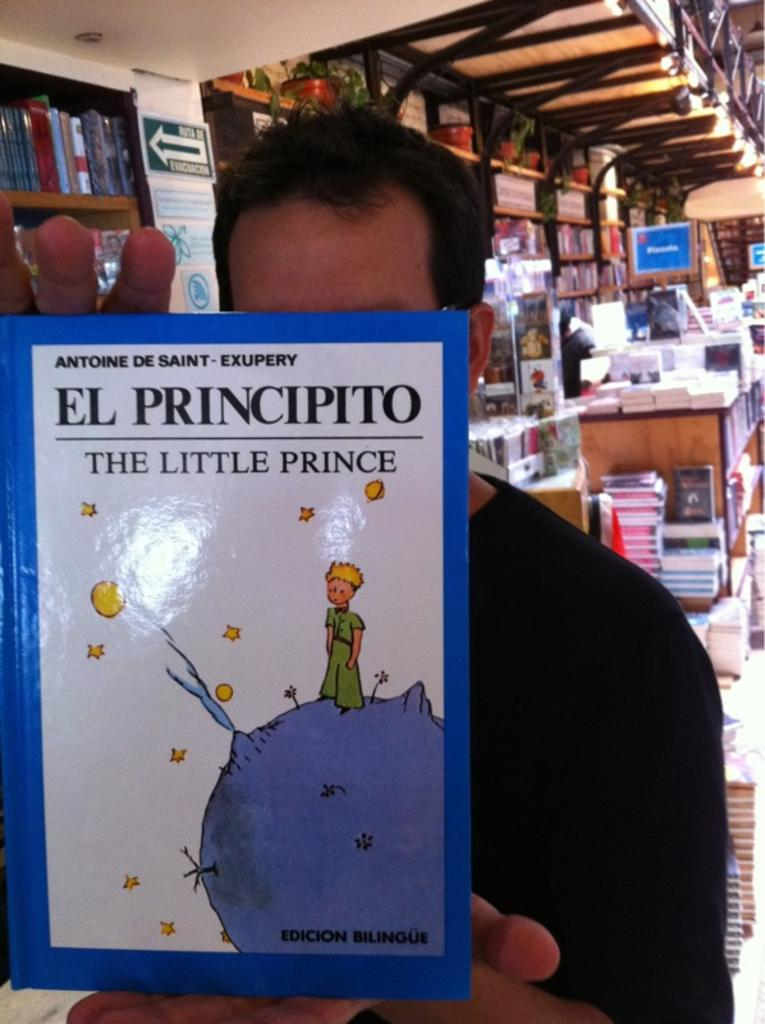What is the person in the image holding? The person is holding a book in the image. How many books can be seen in the image? There are many books visible in the image. What else can be seen at the top of the image? There are plant pots at the top of the image. What type of boat can be seen in the image? There is no boat present in the image. Can you hear the person's voice in the image? The image is a still photograph, so there is no sound or voice present. 